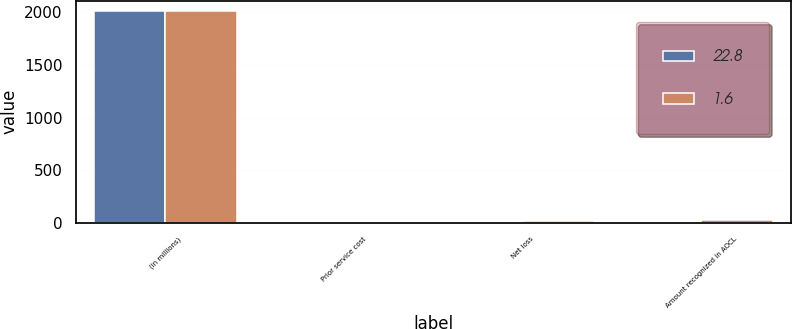Convert chart. <chart><loc_0><loc_0><loc_500><loc_500><stacked_bar_chart><ecel><fcel>(in millions)<fcel>Prior service cost<fcel>Net loss<fcel>Amount recognized in AOCL<nl><fcel>22.8<fcel>2011<fcel>2.2<fcel>3.8<fcel>1.6<nl><fcel>1.6<fcel>2010<fcel>2.5<fcel>20.3<fcel>22.8<nl></chart> 